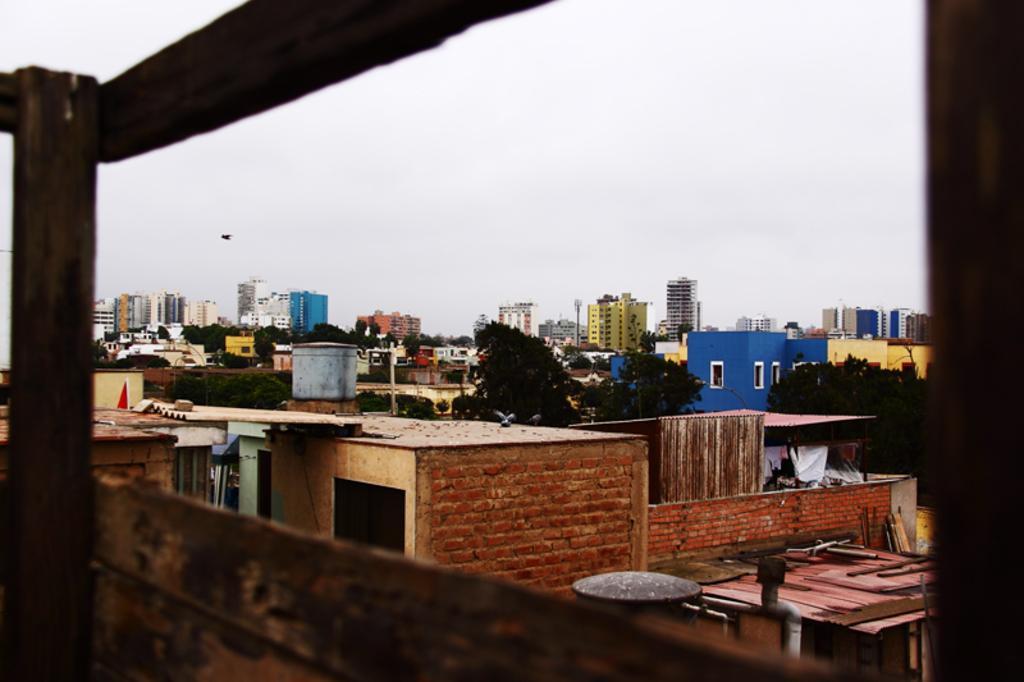Please provide a concise description of this image. In this picture I can see the buildings, trees and shed. On the left there is a bird which is flying in the air. In the background I can see the sky and clouds. In the center I can see the water barrels. 